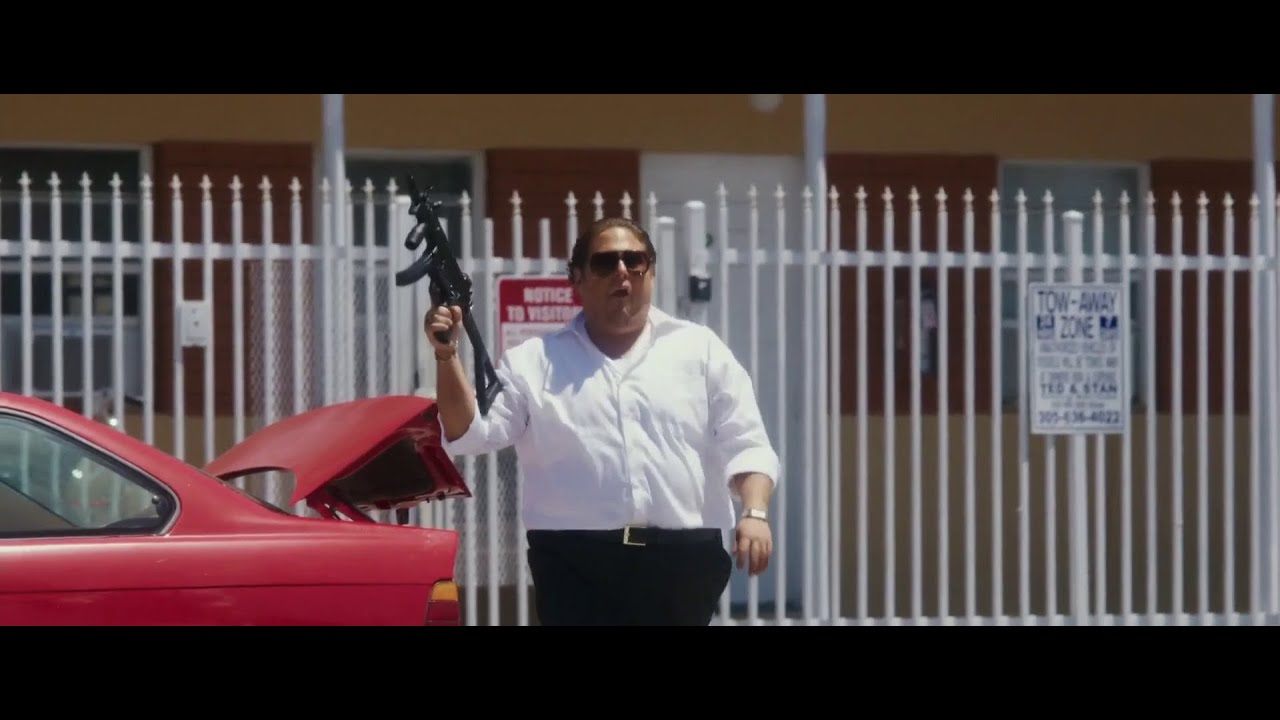What emotion does the person in the image seem to convey with his expression and posture? The individual in the image appears to convey determination and urgency, as evidenced by his grip on the gun and forward movement. His sunglasses hide his eyes, adding a layer of mystery to his emotional state. 